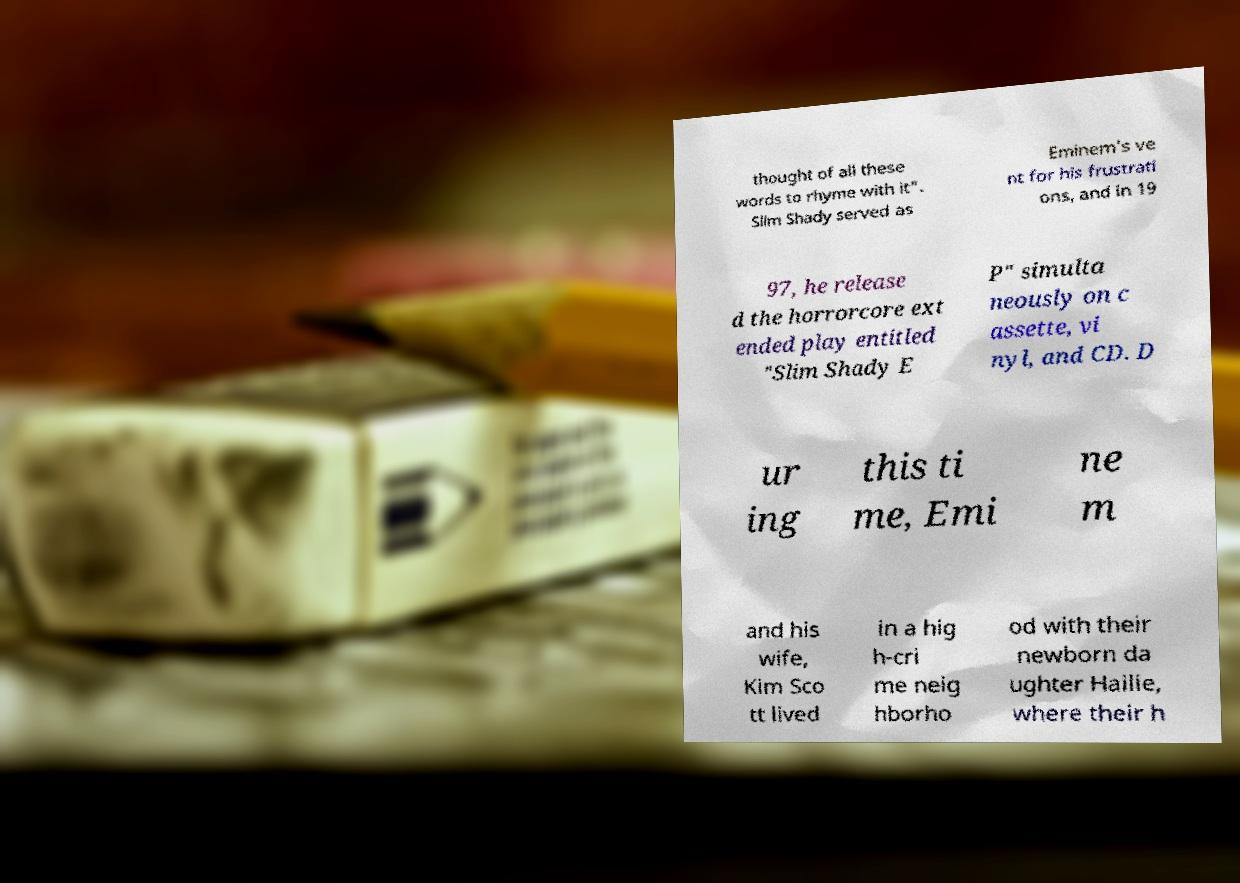Please identify and transcribe the text found in this image. thought of all these words to rhyme with it". Slim Shady served as Eminem's ve nt for his frustrati ons, and in 19 97, he release d the horrorcore ext ended play entitled "Slim Shady E P" simulta neously on c assette, vi nyl, and CD. D ur ing this ti me, Emi ne m and his wife, Kim Sco tt lived in a hig h-cri me neig hborho od with their newborn da ughter Hailie, where their h 